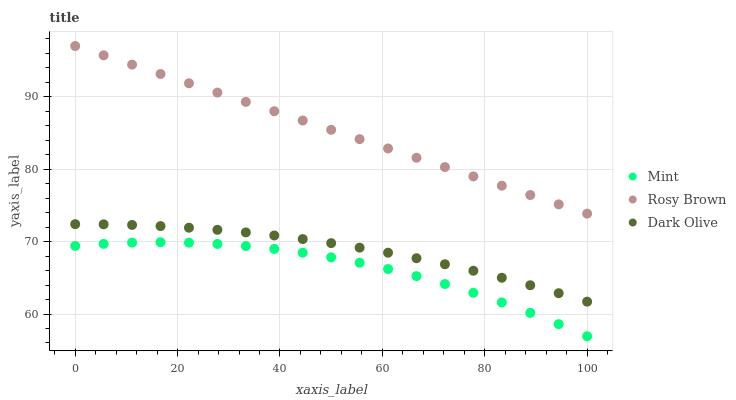Does Mint have the minimum area under the curve?
Answer yes or no. Yes. Does Rosy Brown have the maximum area under the curve?
Answer yes or no. Yes. Does Rosy Brown have the minimum area under the curve?
Answer yes or no. No. Does Mint have the maximum area under the curve?
Answer yes or no. No. Is Rosy Brown the smoothest?
Answer yes or no. Yes. Is Mint the roughest?
Answer yes or no. Yes. Is Mint the smoothest?
Answer yes or no. No. Is Rosy Brown the roughest?
Answer yes or no. No. Does Mint have the lowest value?
Answer yes or no. Yes. Does Rosy Brown have the lowest value?
Answer yes or no. No. Does Rosy Brown have the highest value?
Answer yes or no. Yes. Does Mint have the highest value?
Answer yes or no. No. Is Dark Olive less than Rosy Brown?
Answer yes or no. Yes. Is Rosy Brown greater than Dark Olive?
Answer yes or no. Yes. Does Dark Olive intersect Rosy Brown?
Answer yes or no. No. 